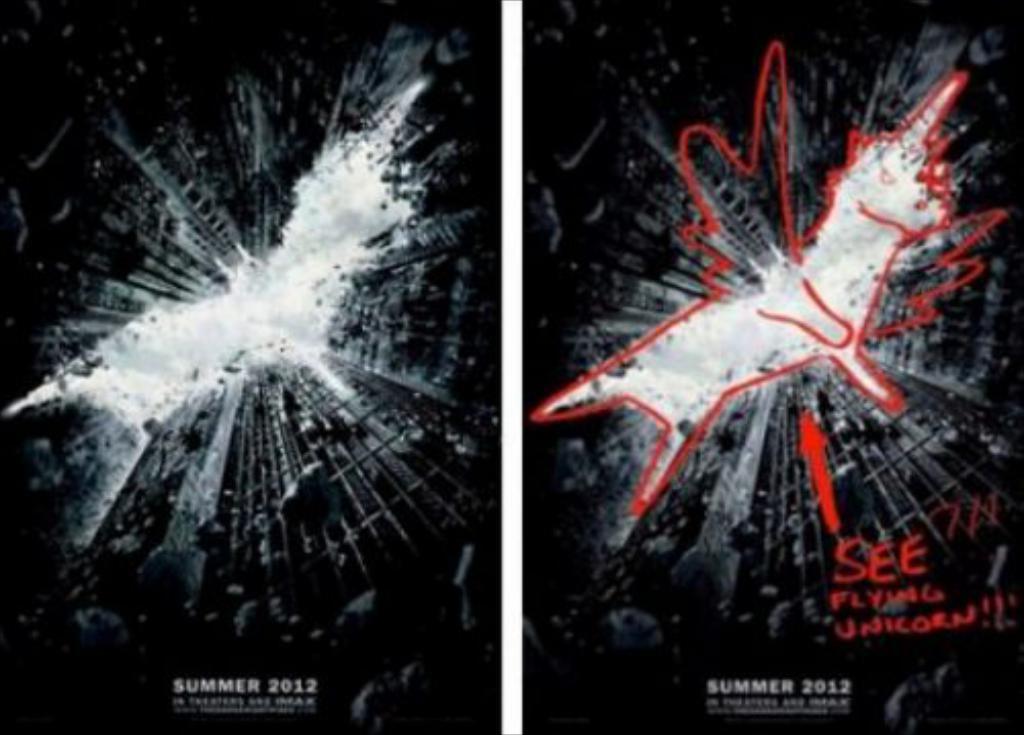What year was the film released?
Provide a succinct answer. 2012. In what season was the movie released?
Ensure brevity in your answer.  Summer. 